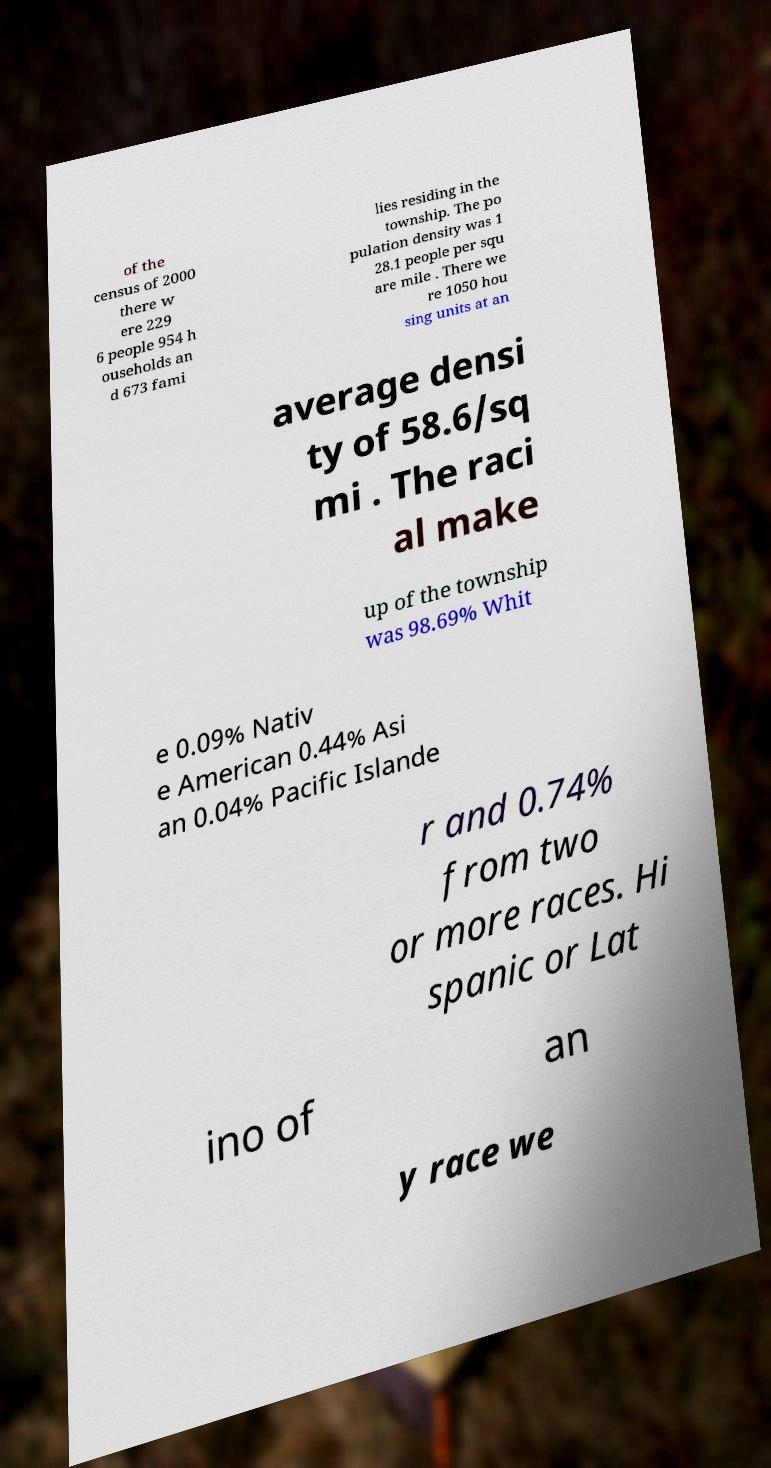Can you read and provide the text displayed in the image?This photo seems to have some interesting text. Can you extract and type it out for me? of the census of 2000 there w ere 229 6 people 954 h ouseholds an d 673 fami lies residing in the township. The po pulation density was 1 28.1 people per squ are mile . There we re 1050 hou sing units at an average densi ty of 58.6/sq mi . The raci al make up of the township was 98.69% Whit e 0.09% Nativ e American 0.44% Asi an 0.04% Pacific Islande r and 0.74% from two or more races. Hi spanic or Lat ino of an y race we 